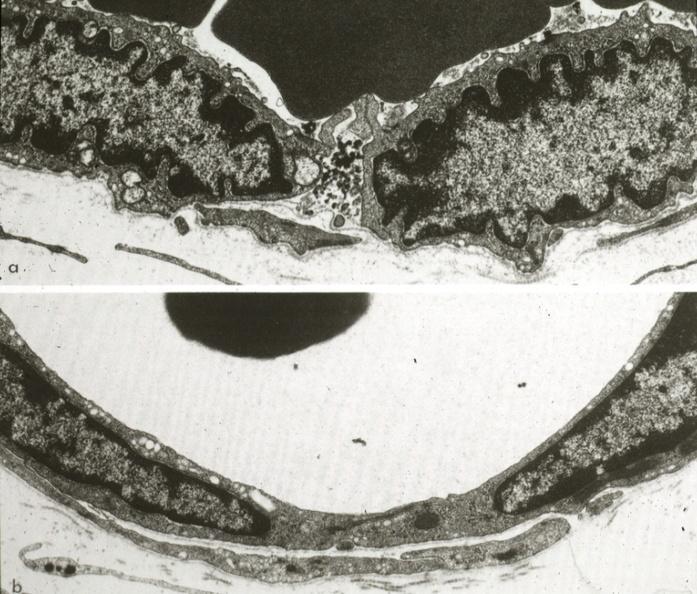s quite good liver present?
Answer the question using a single word or phrase. No 